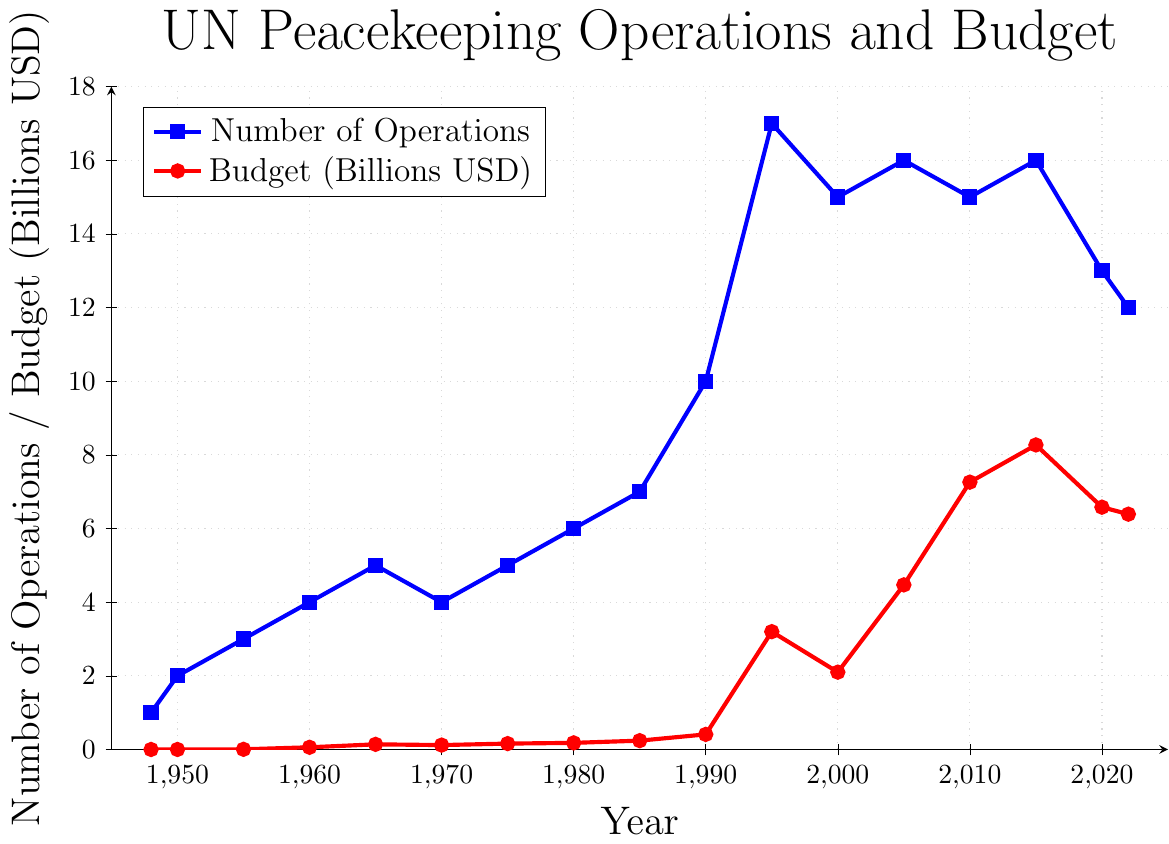How many peacekeeping operations were there in 1980 compared to 2022? In 1980, there were 6 operations, and in 2022 there were 12.
Answer: In 1980, there were 6; in 2022, there were 12 What is the total budget for peacekeeping operations in 2005 and 2010? Add the 2005 budget (4.47 billion USD) to the 2010 budget (7.26 billion USD): 4.47 + 7.26 = 11.73 billion USD.
Answer: 11.73 billion USD Between which years did the number of peacekeeping operations increase the most? The number of peacekeeping operations increased the most between 1985 and 1990, from 7 to 10, an increase of 3 operations.
Answer: Between 1985 and 1990 Which year had the highest budget for peacekeeping operations, and what was the budget? 2015 had the highest budget, 8.27 billion USD.
Answer: 2015, 8.27 billion USD How many years had a higher budget than 2000? Counting the years with a budget higher than 2.1 billion USD: 2005, 2010, 2015, 2020, and 2022. That makes 5 years.
Answer: 5 years When did the number of peacekeeping operations peak, and what was the total budget in that year? The number of peacekeeping operations peaked in 1995 with 17 operations. The total budget that year was 3.2 billion USD.
Answer: 1995, 3.2 billion USD How much did the budget for peacekeeping operations change between 1995 and 2000? The budget decreased from 3.2 billion USD in 1995 to 2.1 billion USD in 2000. The change is 3.2 - 2.1 = 1.1 billion USD.
Answer: 1.1 billion USD decrease Compare the number of operations and budget in 1965 and 1970. In 1965, there were 5 operations and a budget of 0.14 billion USD. In 1970, there were 4 operations and a budget of 0.12 billion USD.
Answer: 1965 had one more operation and a higher budget What is the average budget for UN peacekeeping operations from 1980 to 1990? Sum the budgets from 1980 (0.18 billion USD), 1985 (0.24 billion USD), and 1990 (0.41 billion USD), then divide by 3. (0.18 + 0.24 + 0.41) / 3 = 0.83 / 3 ≈ 0.28 billion USD.
Answer: 0.28 billion USD 